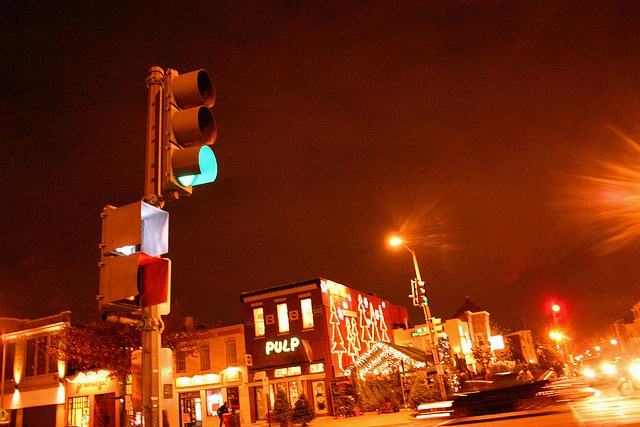Describe the objects in this image and their specific colors. I can see traffic light in black, brown, maroon, and lavender tones, traffic light in black, maroon, and red tones, car in black, orange, ivory, khaki, and gold tones, bench in black, ivory, brown, maroon, and red tones, and traffic light in black, maroon, red, and khaki tones in this image. 